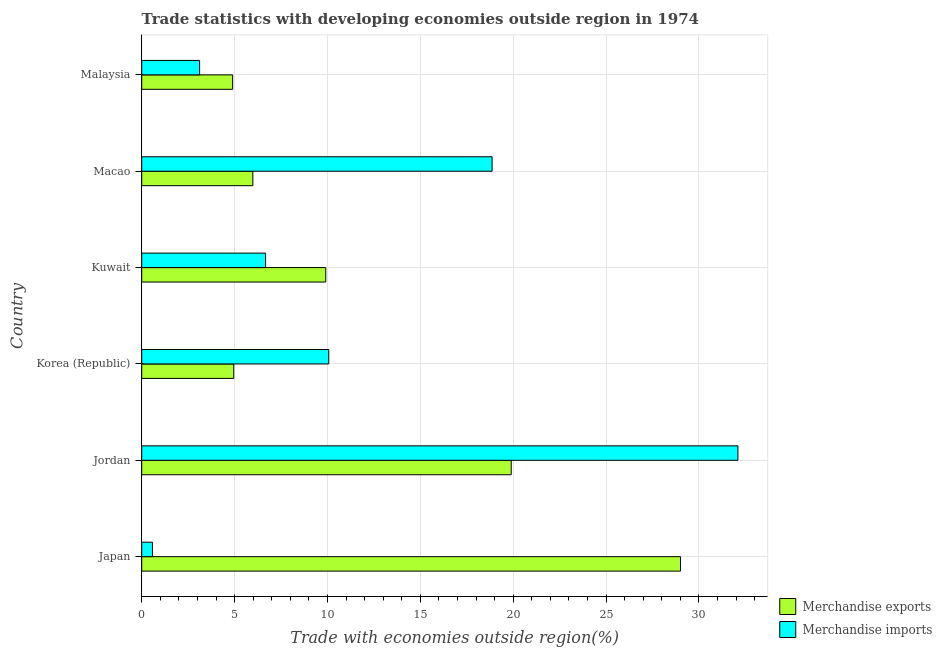How many different coloured bars are there?
Keep it short and to the point. 2. What is the label of the 5th group of bars from the top?
Your response must be concise. Jordan. In how many cases, is the number of bars for a given country not equal to the number of legend labels?
Offer a terse response. 0. What is the merchandise exports in Jordan?
Offer a terse response. 19.89. Across all countries, what is the maximum merchandise imports?
Make the answer very short. 32.1. Across all countries, what is the minimum merchandise imports?
Offer a terse response. 0.58. In which country was the merchandise imports maximum?
Make the answer very short. Jordan. What is the total merchandise exports in the graph?
Give a very brief answer. 74.64. What is the difference between the merchandise imports in Kuwait and that in Malaysia?
Offer a terse response. 3.55. What is the difference between the merchandise imports in Malaysia and the merchandise exports in Jordan?
Keep it short and to the point. -16.78. What is the average merchandise imports per country?
Offer a very short reply. 11.9. What is the difference between the merchandise imports and merchandise exports in Kuwait?
Make the answer very short. -3.24. In how many countries, is the merchandise exports greater than 19 %?
Ensure brevity in your answer.  2. What is the ratio of the merchandise imports in Jordan to that in Korea (Republic)?
Offer a terse response. 3.19. What is the difference between the highest and the second highest merchandise exports?
Your answer should be compact. 9.11. What is the difference between the highest and the lowest merchandise imports?
Keep it short and to the point. 31.52. Is the sum of the merchandise exports in Macao and Malaysia greater than the maximum merchandise imports across all countries?
Give a very brief answer. No. What does the 1st bar from the bottom in Kuwait represents?
Keep it short and to the point. Merchandise exports. How many bars are there?
Your response must be concise. 12. Are all the bars in the graph horizontal?
Your answer should be compact. Yes. What is the difference between two consecutive major ticks on the X-axis?
Your answer should be very brief. 5. Are the values on the major ticks of X-axis written in scientific E-notation?
Provide a succinct answer. No. Does the graph contain any zero values?
Give a very brief answer. No. Does the graph contain grids?
Provide a short and direct response. Yes. How many legend labels are there?
Give a very brief answer. 2. What is the title of the graph?
Give a very brief answer. Trade statistics with developing economies outside region in 1974. What is the label or title of the X-axis?
Keep it short and to the point. Trade with economies outside region(%). What is the label or title of the Y-axis?
Ensure brevity in your answer.  Country. What is the Trade with economies outside region(%) of Merchandise exports in Japan?
Provide a short and direct response. 29.01. What is the Trade with economies outside region(%) in Merchandise imports in Japan?
Your answer should be compact. 0.58. What is the Trade with economies outside region(%) in Merchandise exports in Jordan?
Offer a terse response. 19.89. What is the Trade with economies outside region(%) in Merchandise imports in Jordan?
Your answer should be compact. 32.1. What is the Trade with economies outside region(%) of Merchandise exports in Korea (Republic)?
Your answer should be compact. 4.95. What is the Trade with economies outside region(%) of Merchandise imports in Korea (Republic)?
Your answer should be very brief. 10.07. What is the Trade with economies outside region(%) of Merchandise exports in Kuwait?
Provide a succinct answer. 9.91. What is the Trade with economies outside region(%) of Merchandise imports in Kuwait?
Provide a short and direct response. 6.67. What is the Trade with economies outside region(%) in Merchandise exports in Macao?
Your response must be concise. 5.98. What is the Trade with economies outside region(%) in Merchandise imports in Macao?
Provide a short and direct response. 18.86. What is the Trade with economies outside region(%) of Merchandise exports in Malaysia?
Provide a succinct answer. 4.89. What is the Trade with economies outside region(%) in Merchandise imports in Malaysia?
Keep it short and to the point. 3.12. Across all countries, what is the maximum Trade with economies outside region(%) of Merchandise exports?
Offer a terse response. 29.01. Across all countries, what is the maximum Trade with economies outside region(%) of Merchandise imports?
Give a very brief answer. 32.1. Across all countries, what is the minimum Trade with economies outside region(%) of Merchandise exports?
Offer a very short reply. 4.89. Across all countries, what is the minimum Trade with economies outside region(%) in Merchandise imports?
Your response must be concise. 0.58. What is the total Trade with economies outside region(%) of Merchandise exports in the graph?
Give a very brief answer. 74.64. What is the total Trade with economies outside region(%) in Merchandise imports in the graph?
Provide a succinct answer. 71.39. What is the difference between the Trade with economies outside region(%) in Merchandise exports in Japan and that in Jordan?
Offer a very short reply. 9.11. What is the difference between the Trade with economies outside region(%) of Merchandise imports in Japan and that in Jordan?
Ensure brevity in your answer.  -31.52. What is the difference between the Trade with economies outside region(%) of Merchandise exports in Japan and that in Korea (Republic)?
Ensure brevity in your answer.  24.05. What is the difference between the Trade with economies outside region(%) of Merchandise imports in Japan and that in Korea (Republic)?
Offer a terse response. -9.49. What is the difference between the Trade with economies outside region(%) in Merchandise exports in Japan and that in Kuwait?
Make the answer very short. 19.1. What is the difference between the Trade with economies outside region(%) in Merchandise imports in Japan and that in Kuwait?
Make the answer very short. -6.09. What is the difference between the Trade with economies outside region(%) of Merchandise exports in Japan and that in Macao?
Keep it short and to the point. 23.02. What is the difference between the Trade with economies outside region(%) in Merchandise imports in Japan and that in Macao?
Offer a very short reply. -18.29. What is the difference between the Trade with economies outside region(%) in Merchandise exports in Japan and that in Malaysia?
Keep it short and to the point. 24.11. What is the difference between the Trade with economies outside region(%) of Merchandise imports in Japan and that in Malaysia?
Give a very brief answer. -2.54. What is the difference between the Trade with economies outside region(%) of Merchandise exports in Jordan and that in Korea (Republic)?
Offer a terse response. 14.94. What is the difference between the Trade with economies outside region(%) of Merchandise imports in Jordan and that in Korea (Republic)?
Ensure brevity in your answer.  22.03. What is the difference between the Trade with economies outside region(%) of Merchandise exports in Jordan and that in Kuwait?
Your response must be concise. 9.99. What is the difference between the Trade with economies outside region(%) in Merchandise imports in Jordan and that in Kuwait?
Keep it short and to the point. 25.43. What is the difference between the Trade with economies outside region(%) in Merchandise exports in Jordan and that in Macao?
Ensure brevity in your answer.  13.91. What is the difference between the Trade with economies outside region(%) in Merchandise imports in Jordan and that in Macao?
Offer a very short reply. 13.23. What is the difference between the Trade with economies outside region(%) of Merchandise exports in Jordan and that in Malaysia?
Provide a succinct answer. 15. What is the difference between the Trade with economies outside region(%) in Merchandise imports in Jordan and that in Malaysia?
Provide a short and direct response. 28.98. What is the difference between the Trade with economies outside region(%) of Merchandise exports in Korea (Republic) and that in Kuwait?
Your response must be concise. -4.95. What is the difference between the Trade with economies outside region(%) of Merchandise imports in Korea (Republic) and that in Kuwait?
Your answer should be very brief. 3.4. What is the difference between the Trade with economies outside region(%) in Merchandise exports in Korea (Republic) and that in Macao?
Offer a terse response. -1.03. What is the difference between the Trade with economies outside region(%) of Merchandise imports in Korea (Republic) and that in Macao?
Offer a terse response. -8.79. What is the difference between the Trade with economies outside region(%) in Merchandise exports in Korea (Republic) and that in Malaysia?
Your response must be concise. 0.06. What is the difference between the Trade with economies outside region(%) of Merchandise imports in Korea (Republic) and that in Malaysia?
Ensure brevity in your answer.  6.95. What is the difference between the Trade with economies outside region(%) of Merchandise exports in Kuwait and that in Macao?
Provide a succinct answer. 3.93. What is the difference between the Trade with economies outside region(%) in Merchandise imports in Kuwait and that in Macao?
Keep it short and to the point. -12.2. What is the difference between the Trade with economies outside region(%) in Merchandise exports in Kuwait and that in Malaysia?
Provide a short and direct response. 5.01. What is the difference between the Trade with economies outside region(%) of Merchandise imports in Kuwait and that in Malaysia?
Give a very brief answer. 3.55. What is the difference between the Trade with economies outside region(%) of Merchandise exports in Macao and that in Malaysia?
Provide a short and direct response. 1.09. What is the difference between the Trade with economies outside region(%) of Merchandise imports in Macao and that in Malaysia?
Your answer should be very brief. 15.75. What is the difference between the Trade with economies outside region(%) in Merchandise exports in Japan and the Trade with economies outside region(%) in Merchandise imports in Jordan?
Ensure brevity in your answer.  -3.09. What is the difference between the Trade with economies outside region(%) in Merchandise exports in Japan and the Trade with economies outside region(%) in Merchandise imports in Korea (Republic)?
Your response must be concise. 18.94. What is the difference between the Trade with economies outside region(%) in Merchandise exports in Japan and the Trade with economies outside region(%) in Merchandise imports in Kuwait?
Offer a terse response. 22.34. What is the difference between the Trade with economies outside region(%) in Merchandise exports in Japan and the Trade with economies outside region(%) in Merchandise imports in Macao?
Offer a terse response. 10.14. What is the difference between the Trade with economies outside region(%) of Merchandise exports in Japan and the Trade with economies outside region(%) of Merchandise imports in Malaysia?
Keep it short and to the point. 25.89. What is the difference between the Trade with economies outside region(%) in Merchandise exports in Jordan and the Trade with economies outside region(%) in Merchandise imports in Korea (Republic)?
Ensure brevity in your answer.  9.82. What is the difference between the Trade with economies outside region(%) of Merchandise exports in Jordan and the Trade with economies outside region(%) of Merchandise imports in Kuwait?
Your response must be concise. 13.22. What is the difference between the Trade with economies outside region(%) in Merchandise exports in Jordan and the Trade with economies outside region(%) in Merchandise imports in Macao?
Your answer should be compact. 1.03. What is the difference between the Trade with economies outside region(%) of Merchandise exports in Jordan and the Trade with economies outside region(%) of Merchandise imports in Malaysia?
Your answer should be very brief. 16.78. What is the difference between the Trade with economies outside region(%) of Merchandise exports in Korea (Republic) and the Trade with economies outside region(%) of Merchandise imports in Kuwait?
Offer a very short reply. -1.71. What is the difference between the Trade with economies outside region(%) of Merchandise exports in Korea (Republic) and the Trade with economies outside region(%) of Merchandise imports in Macao?
Ensure brevity in your answer.  -13.91. What is the difference between the Trade with economies outside region(%) in Merchandise exports in Korea (Republic) and the Trade with economies outside region(%) in Merchandise imports in Malaysia?
Provide a short and direct response. 1.84. What is the difference between the Trade with economies outside region(%) of Merchandise exports in Kuwait and the Trade with economies outside region(%) of Merchandise imports in Macao?
Your answer should be compact. -8.96. What is the difference between the Trade with economies outside region(%) in Merchandise exports in Kuwait and the Trade with economies outside region(%) in Merchandise imports in Malaysia?
Ensure brevity in your answer.  6.79. What is the difference between the Trade with economies outside region(%) in Merchandise exports in Macao and the Trade with economies outside region(%) in Merchandise imports in Malaysia?
Your response must be concise. 2.87. What is the average Trade with economies outside region(%) of Merchandise exports per country?
Your answer should be very brief. 12.44. What is the average Trade with economies outside region(%) of Merchandise imports per country?
Your response must be concise. 11.9. What is the difference between the Trade with economies outside region(%) in Merchandise exports and Trade with economies outside region(%) in Merchandise imports in Japan?
Provide a succinct answer. 28.43. What is the difference between the Trade with economies outside region(%) of Merchandise exports and Trade with economies outside region(%) of Merchandise imports in Jordan?
Provide a succinct answer. -12.2. What is the difference between the Trade with economies outside region(%) of Merchandise exports and Trade with economies outside region(%) of Merchandise imports in Korea (Republic)?
Give a very brief answer. -5.11. What is the difference between the Trade with economies outside region(%) in Merchandise exports and Trade with economies outside region(%) in Merchandise imports in Kuwait?
Offer a very short reply. 3.24. What is the difference between the Trade with economies outside region(%) of Merchandise exports and Trade with economies outside region(%) of Merchandise imports in Macao?
Provide a succinct answer. -12.88. What is the difference between the Trade with economies outside region(%) of Merchandise exports and Trade with economies outside region(%) of Merchandise imports in Malaysia?
Your answer should be very brief. 1.78. What is the ratio of the Trade with economies outside region(%) in Merchandise exports in Japan to that in Jordan?
Ensure brevity in your answer.  1.46. What is the ratio of the Trade with economies outside region(%) of Merchandise imports in Japan to that in Jordan?
Provide a short and direct response. 0.02. What is the ratio of the Trade with economies outside region(%) of Merchandise exports in Japan to that in Korea (Republic)?
Your response must be concise. 5.85. What is the ratio of the Trade with economies outside region(%) in Merchandise imports in Japan to that in Korea (Republic)?
Offer a terse response. 0.06. What is the ratio of the Trade with economies outside region(%) in Merchandise exports in Japan to that in Kuwait?
Provide a succinct answer. 2.93. What is the ratio of the Trade with economies outside region(%) of Merchandise imports in Japan to that in Kuwait?
Ensure brevity in your answer.  0.09. What is the ratio of the Trade with economies outside region(%) of Merchandise exports in Japan to that in Macao?
Your response must be concise. 4.85. What is the ratio of the Trade with economies outside region(%) of Merchandise imports in Japan to that in Macao?
Your answer should be very brief. 0.03. What is the ratio of the Trade with economies outside region(%) in Merchandise exports in Japan to that in Malaysia?
Offer a very short reply. 5.93. What is the ratio of the Trade with economies outside region(%) of Merchandise imports in Japan to that in Malaysia?
Make the answer very short. 0.19. What is the ratio of the Trade with economies outside region(%) in Merchandise exports in Jordan to that in Korea (Republic)?
Ensure brevity in your answer.  4.02. What is the ratio of the Trade with economies outside region(%) in Merchandise imports in Jordan to that in Korea (Republic)?
Provide a succinct answer. 3.19. What is the ratio of the Trade with economies outside region(%) of Merchandise exports in Jordan to that in Kuwait?
Offer a very short reply. 2.01. What is the ratio of the Trade with economies outside region(%) in Merchandise imports in Jordan to that in Kuwait?
Offer a terse response. 4.81. What is the ratio of the Trade with economies outside region(%) of Merchandise exports in Jordan to that in Macao?
Offer a terse response. 3.33. What is the ratio of the Trade with economies outside region(%) in Merchandise imports in Jordan to that in Macao?
Your response must be concise. 1.7. What is the ratio of the Trade with economies outside region(%) of Merchandise exports in Jordan to that in Malaysia?
Your response must be concise. 4.06. What is the ratio of the Trade with economies outside region(%) in Merchandise imports in Jordan to that in Malaysia?
Provide a short and direct response. 10.3. What is the ratio of the Trade with economies outside region(%) in Merchandise exports in Korea (Republic) to that in Kuwait?
Ensure brevity in your answer.  0.5. What is the ratio of the Trade with economies outside region(%) in Merchandise imports in Korea (Republic) to that in Kuwait?
Keep it short and to the point. 1.51. What is the ratio of the Trade with economies outside region(%) in Merchandise exports in Korea (Republic) to that in Macao?
Give a very brief answer. 0.83. What is the ratio of the Trade with economies outside region(%) of Merchandise imports in Korea (Republic) to that in Macao?
Your response must be concise. 0.53. What is the ratio of the Trade with economies outside region(%) in Merchandise exports in Korea (Republic) to that in Malaysia?
Ensure brevity in your answer.  1.01. What is the ratio of the Trade with economies outside region(%) of Merchandise imports in Korea (Republic) to that in Malaysia?
Ensure brevity in your answer.  3.23. What is the ratio of the Trade with economies outside region(%) of Merchandise exports in Kuwait to that in Macao?
Offer a terse response. 1.66. What is the ratio of the Trade with economies outside region(%) in Merchandise imports in Kuwait to that in Macao?
Make the answer very short. 0.35. What is the ratio of the Trade with economies outside region(%) of Merchandise exports in Kuwait to that in Malaysia?
Ensure brevity in your answer.  2.02. What is the ratio of the Trade with economies outside region(%) of Merchandise imports in Kuwait to that in Malaysia?
Your answer should be compact. 2.14. What is the ratio of the Trade with economies outside region(%) in Merchandise exports in Macao to that in Malaysia?
Your response must be concise. 1.22. What is the ratio of the Trade with economies outside region(%) of Merchandise imports in Macao to that in Malaysia?
Your response must be concise. 6.05. What is the difference between the highest and the second highest Trade with economies outside region(%) of Merchandise exports?
Make the answer very short. 9.11. What is the difference between the highest and the second highest Trade with economies outside region(%) of Merchandise imports?
Keep it short and to the point. 13.23. What is the difference between the highest and the lowest Trade with economies outside region(%) of Merchandise exports?
Provide a succinct answer. 24.11. What is the difference between the highest and the lowest Trade with economies outside region(%) of Merchandise imports?
Ensure brevity in your answer.  31.52. 